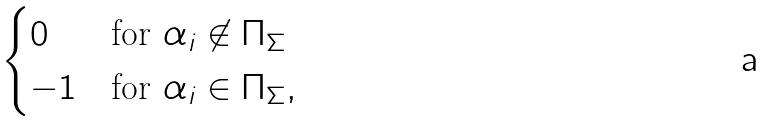<formula> <loc_0><loc_0><loc_500><loc_500>\begin{cases} 0 & \text {for } \alpha _ { i } \not \in \Pi _ { \Sigma } \\ - 1 & \text {for } \alpha _ { i } \in \Pi _ { \Sigma } , \end{cases}</formula> 